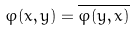<formula> <loc_0><loc_0><loc_500><loc_500>\varphi ( x , y ) = \overline { \varphi ( y , x ) }</formula> 